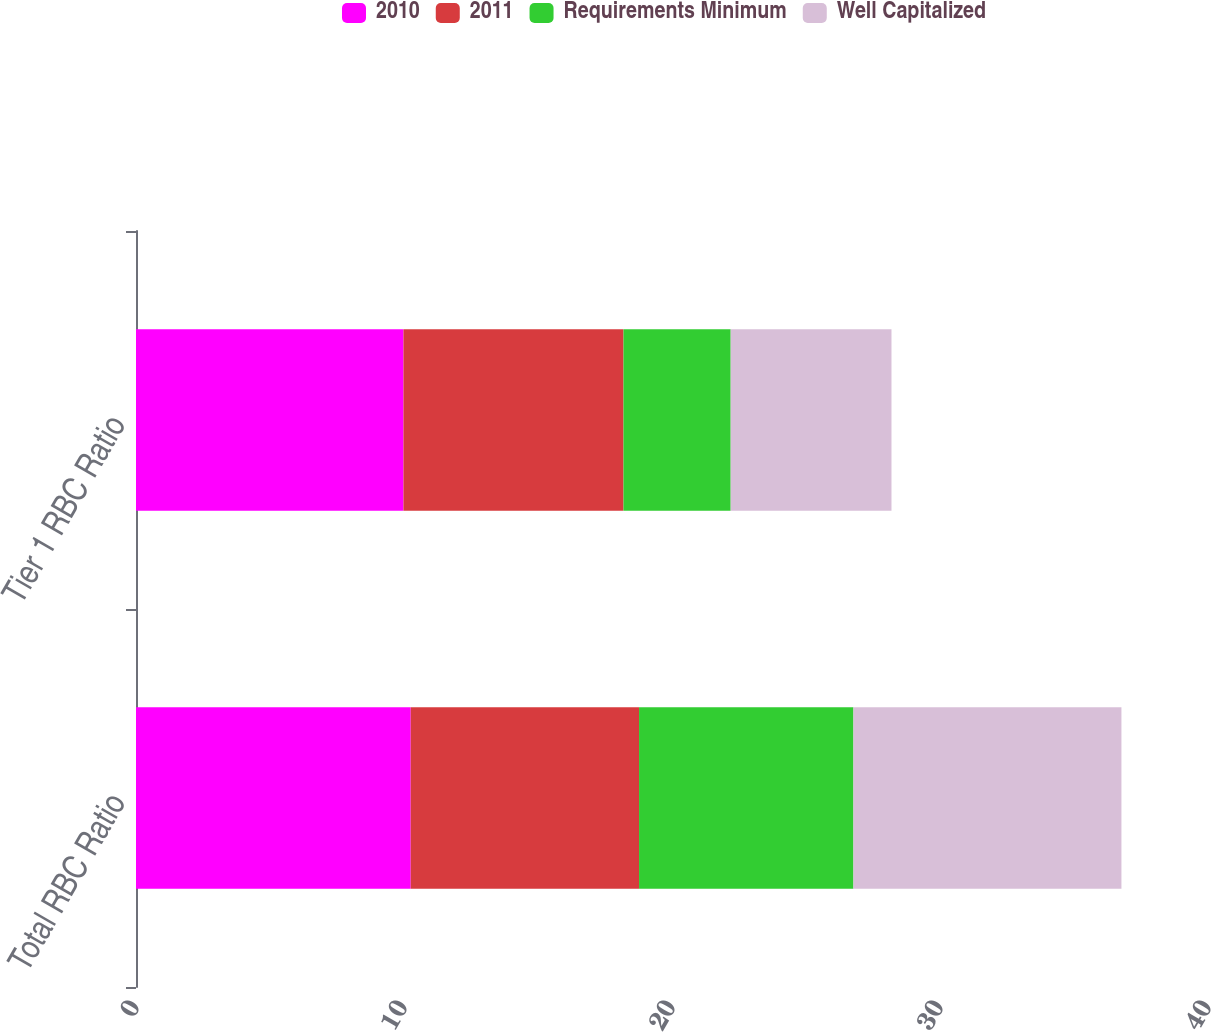<chart> <loc_0><loc_0><loc_500><loc_500><stacked_bar_chart><ecel><fcel>Total RBC Ratio<fcel>Tier 1 RBC Ratio<nl><fcel>2010<fcel>10.25<fcel>9.98<nl><fcel>2011<fcel>8.52<fcel>8.21<nl><fcel>Requirements Minimum<fcel>8<fcel>4<nl><fcel>Well Capitalized<fcel>10<fcel>6<nl></chart> 